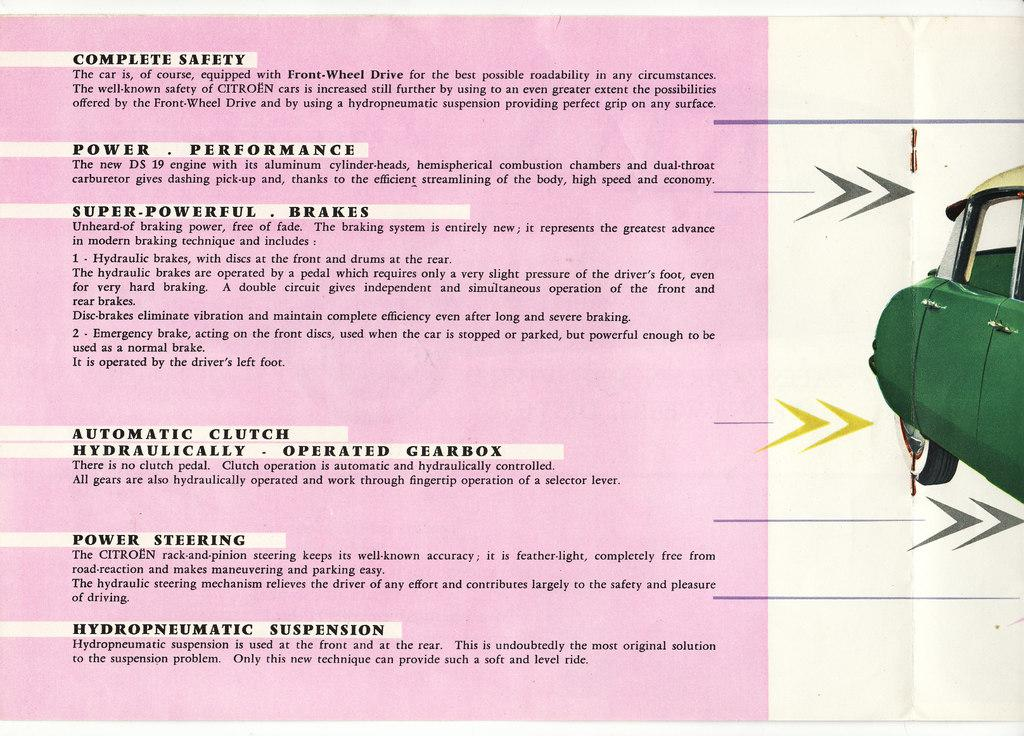What is the main activity being depicted in the image? The image depicts paper cutting. Where can text be found in the image? There is text on the left side of the image. What type of image is on the right side of the image? There is a car picture on the right side of the image. What is the grandfather's voice like in the image? There is no mention of a grandfather or any voice in the image; it focuses on paper cutting and the presence of text and a car picture. 